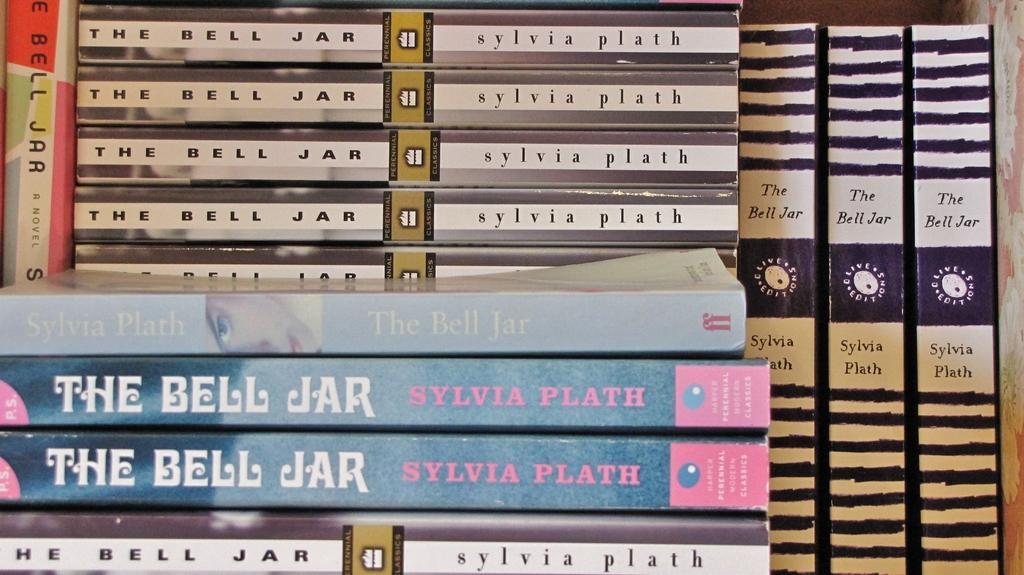<image>
Give a short and clear explanation of the subsequent image. A stack of books titled The Bell Jar 